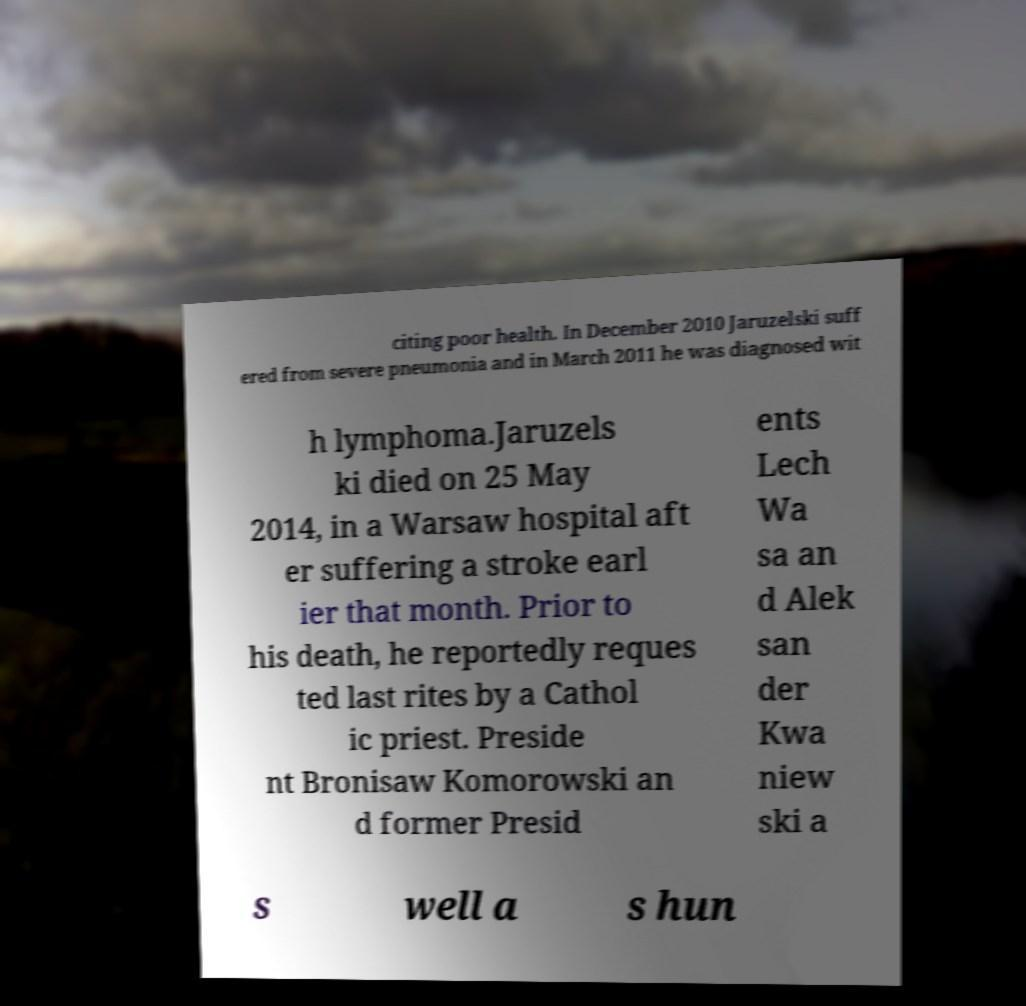Could you extract and type out the text from this image? citing poor health. In December 2010 Jaruzelski suff ered from severe pneumonia and in March 2011 he was diagnosed wit h lymphoma.Jaruzels ki died on 25 May 2014, in a Warsaw hospital aft er suffering a stroke earl ier that month. Prior to his death, he reportedly reques ted last rites by a Cathol ic priest. Preside nt Bronisaw Komorowski an d former Presid ents Lech Wa sa an d Alek san der Kwa niew ski a s well a s hun 